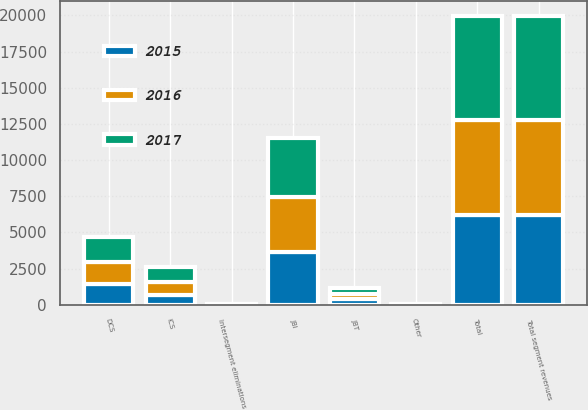Convert chart to OTSL. <chart><loc_0><loc_0><loc_500><loc_500><stacked_bar_chart><ecel><fcel>JBI<fcel>DCS<fcel>ICS<fcel>JBT<fcel>Total segment revenues<fcel>Intersegment eliminations<fcel>Total<fcel>Other<nl><fcel>2017<fcel>4084<fcel>1719<fcel>1025<fcel>378<fcel>7206<fcel>16<fcel>7190<fcel>22<nl><fcel>2016<fcel>3796<fcel>1533<fcel>852<fcel>388<fcel>6569<fcel>14<fcel>6555<fcel>18<nl><fcel>2015<fcel>3665<fcel>1451<fcel>699<fcel>386<fcel>6201<fcel>13<fcel>6188<fcel>17<nl></chart> 